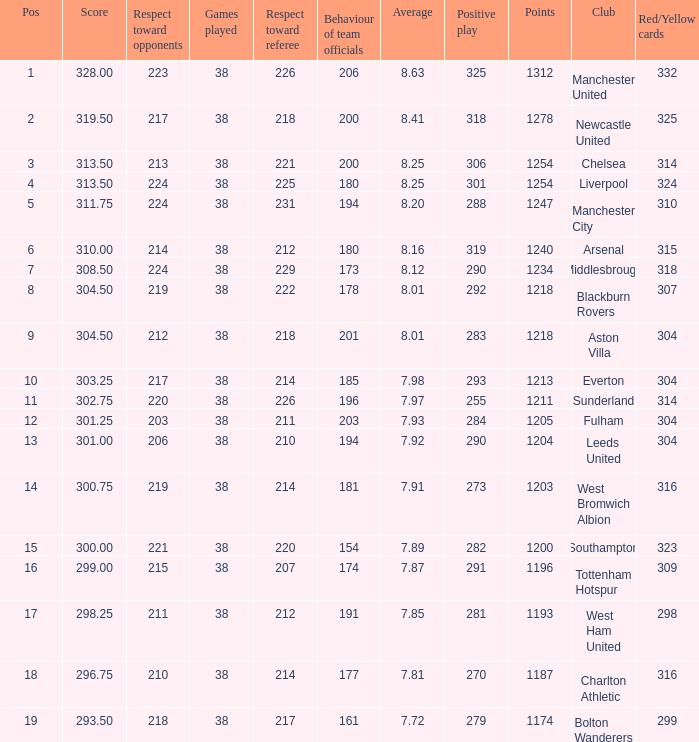Name the most red/yellow cards for positive play being 255 314.0. 